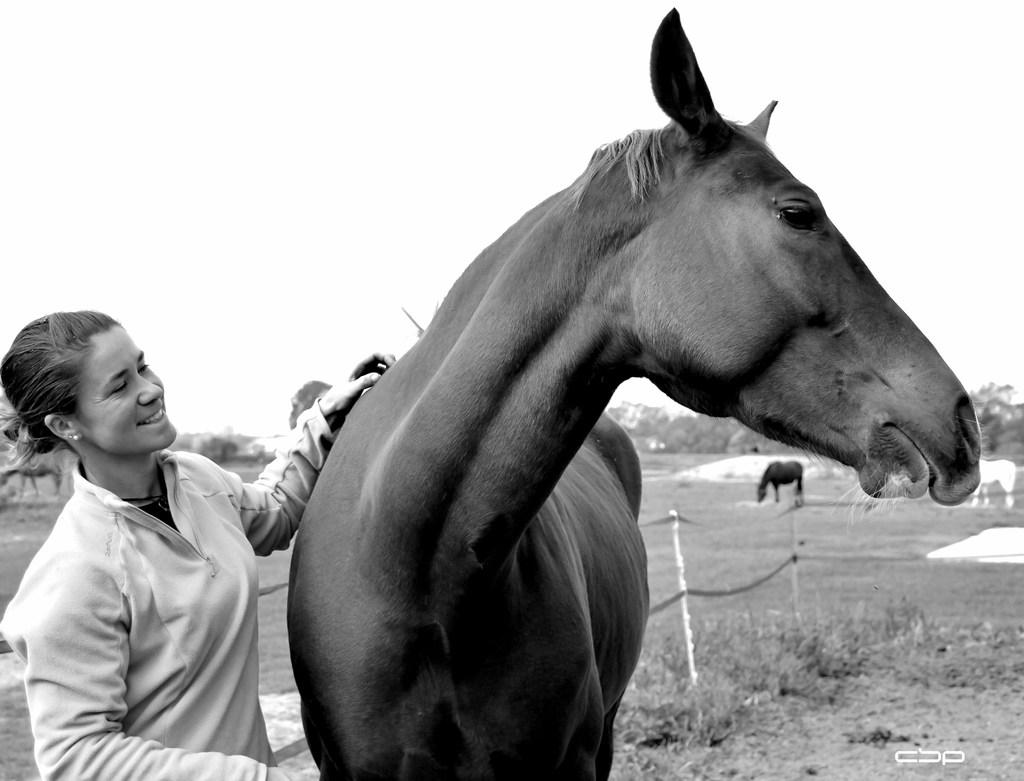What is the main subject of the image? There is a woman standing in the image. Are there any animals present in the image? Yes, there is a horse in the image. What is the setting of the image? The location is a garden. What type of wire is the horse holding in the image? There is no wire present in the image; the horse is not holding anything. 